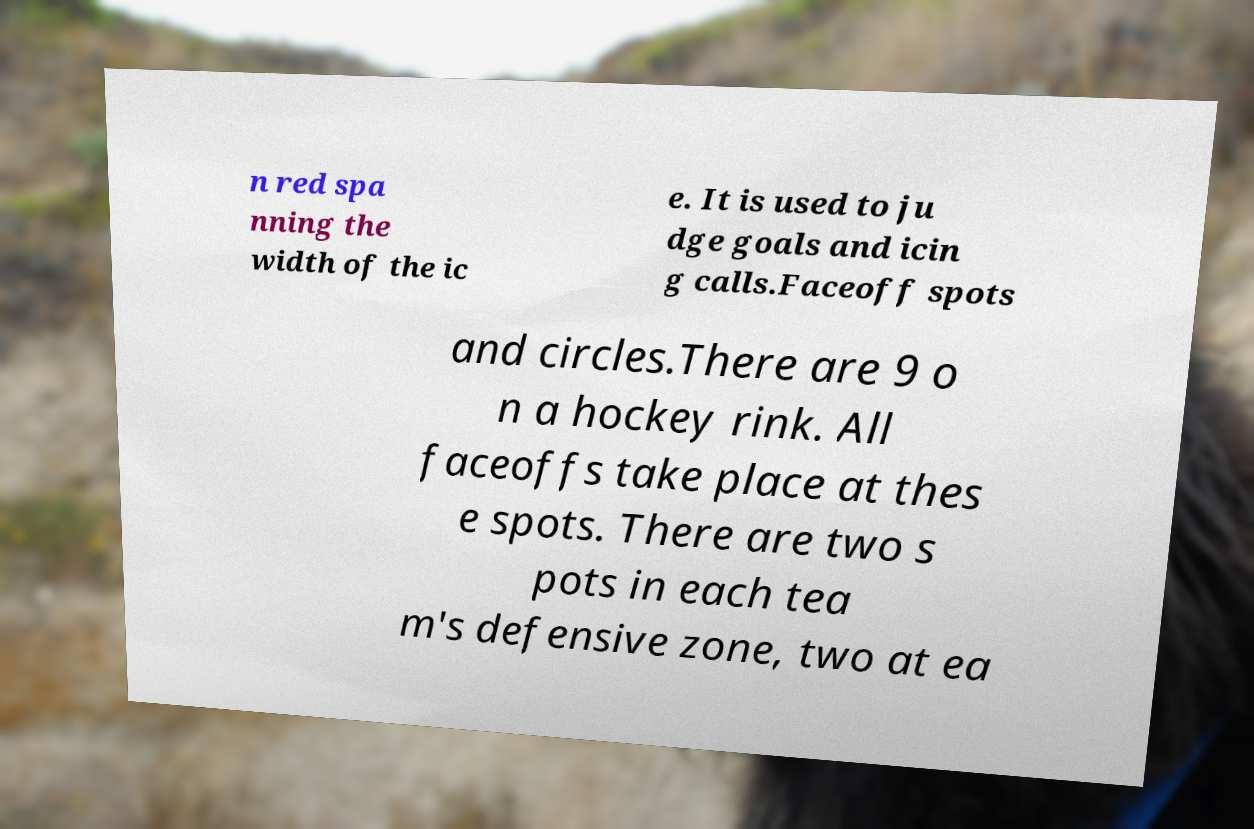Can you read and provide the text displayed in the image?This photo seems to have some interesting text. Can you extract and type it out for me? n red spa nning the width of the ic e. It is used to ju dge goals and icin g calls.Faceoff spots and circles.There are 9 o n a hockey rink. All faceoffs take place at thes e spots. There are two s pots in each tea m's defensive zone, two at ea 